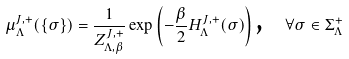Convert formula to latex. <formula><loc_0><loc_0><loc_500><loc_500>\mu ^ { J , + } _ { \Lambda } ( \{ \sigma \} ) = \frac { 1 } { Z ^ { J , + } _ { \Lambda , \beta } } \exp \left ( - \frac { \beta } { 2 } H _ { \Lambda } ^ { J , + } ( \sigma ) \right ) \text {, \ \ } \forall \sigma \in \Sigma ^ { + } _ { \Lambda }</formula> 